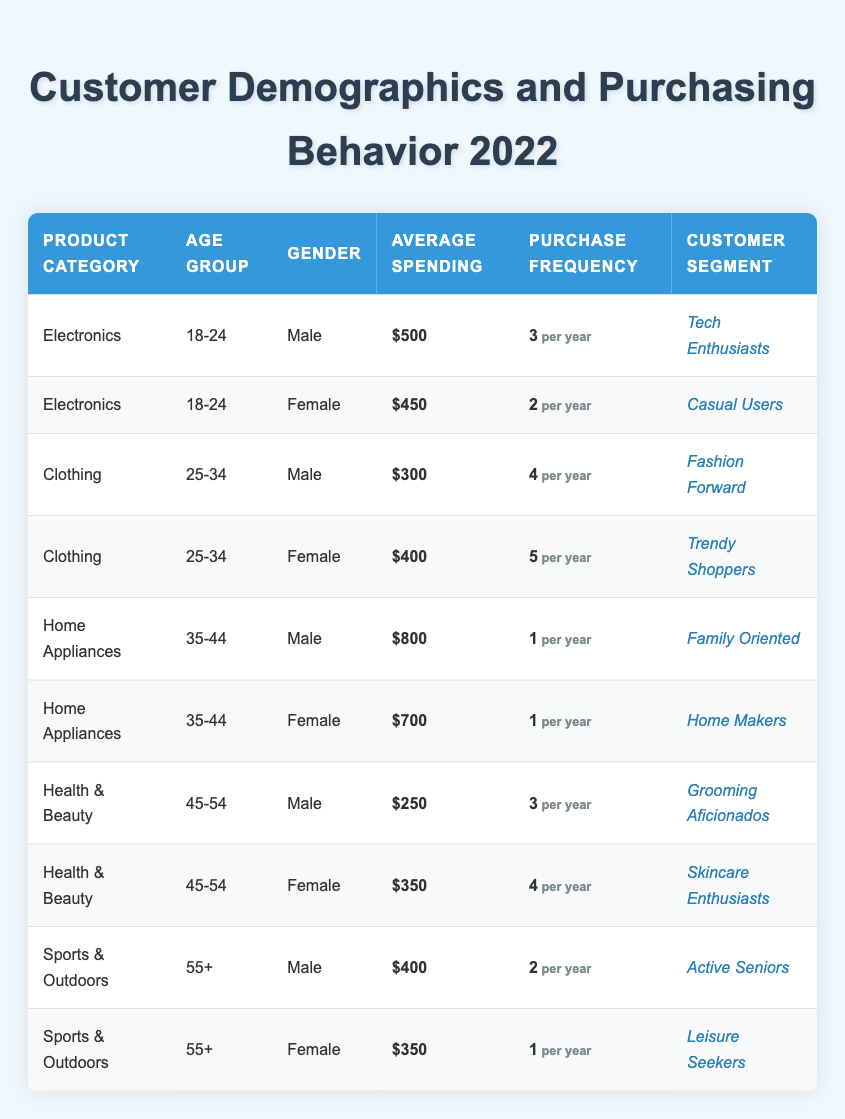What is the average spending of male customers in the Electronics category? From the table, the average spending for male customers in the Electronics category is 500.
Answer: 500 How many males aged 55 and older are categorized as Leisure Seekers? In the table, there is one male (55+) categorized as an Active Senior, and no males are listed as Leisure Seekers, hence the count is zero.
Answer: 0 Which customer segment has the highest average spending in the Home Appliances category? The average spending for male customers in Home Appliances is 800, and for females, it is 700. Hence, the highest average spending is attributed to the Family Oriented segment.
Answer: Family Oriented How many different customer segments are represented for females aged 45-54? The segments are Skincare Enthusiasts (Health & Beauty). There is only one segment for females in this age group, which gives a count of one segment.
Answer: 1 Is the statement "Female customers in the Clothing category have a higher purchase frequency than male customers" true or false? For the Clothing category, females have an average purchase frequency of 5, while males have 4. Therefore, the statement is true.
Answer: True What is the total average spending for customers in the Health & Beauty category? The average spending for male customers is 250 and for females is 350; summing these gives a total of 600.
Answer: 600 Which age group has the highest purchase frequency in the Clothing category? Females aged 25-34 exhibit the highest purchase frequency of 5 in the Clothing category.
Answer: 25-34 How many purchase frequencies equal to 1 are recorded for males aged 35-44? In the Home Appliances category, the only instance of a male aged 35-44 recorded is from the Family Oriented segment, with a purchase frequency of 1. Hence, there is one instance.
Answer: 1 Which product category had more average spending: Health & Beauty or Sports & Outdoors? For Health & Beauty, average spending is (250 + 350)/2 = 300, while for Sports & Outdoors, it is (400 + 350)/2 = 375. Since 375 > 300, Sports & Outdoors has more average spending.
Answer: Sports & Outdoors 